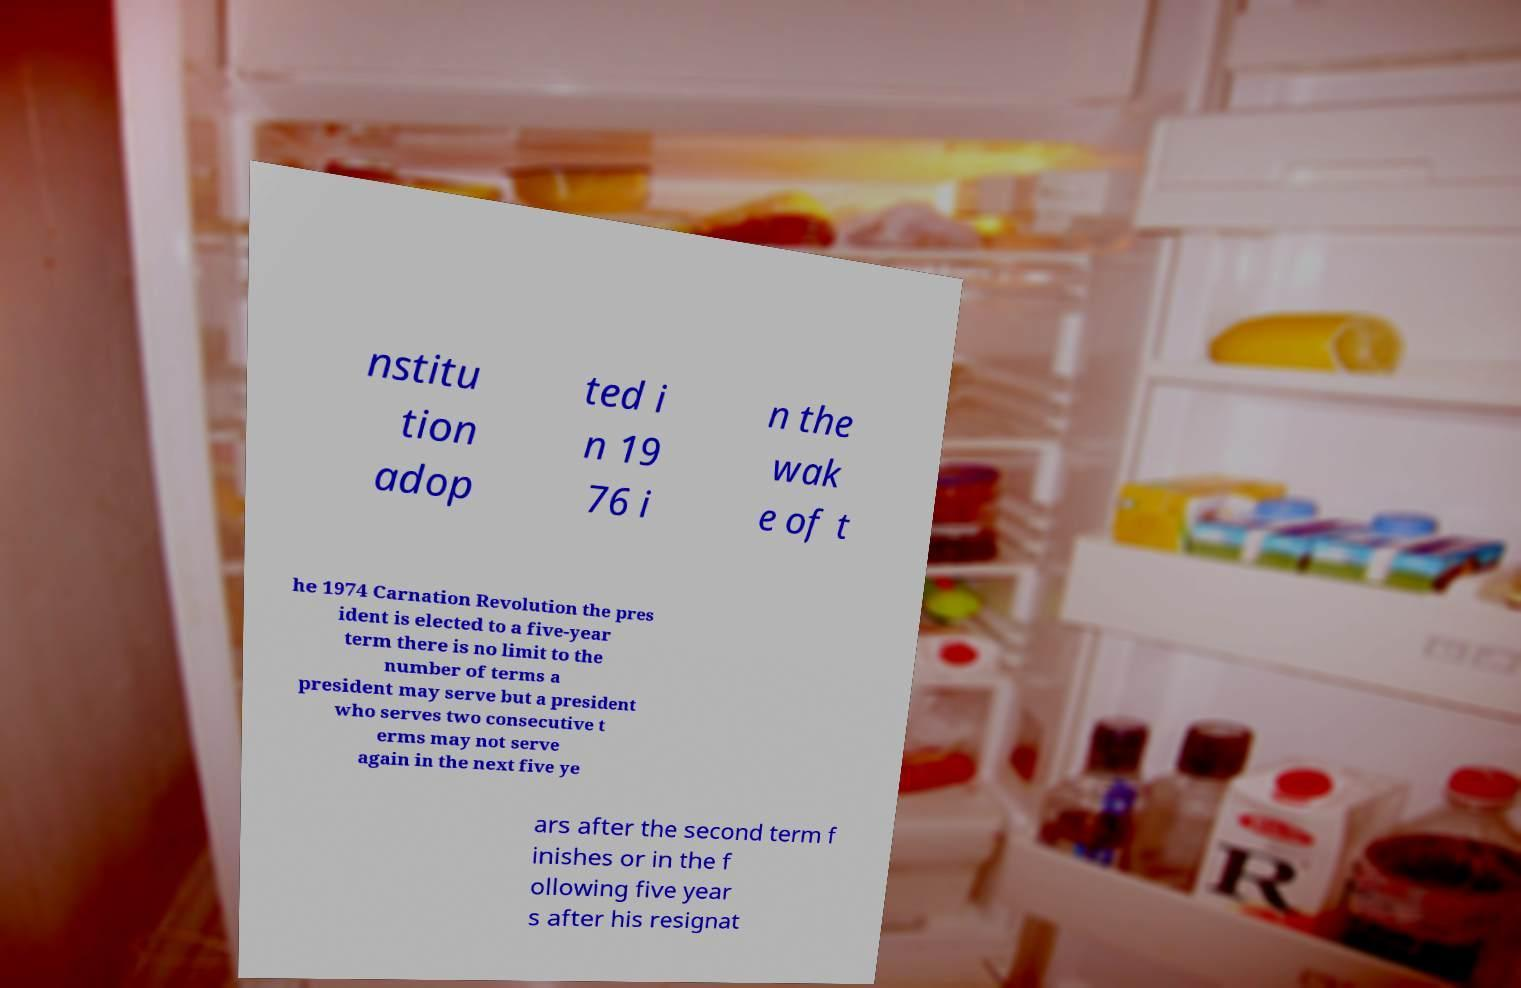There's text embedded in this image that I need extracted. Can you transcribe it verbatim? nstitu tion adop ted i n 19 76 i n the wak e of t he 1974 Carnation Revolution the pres ident is elected to a five-year term there is no limit to the number of terms a president may serve but a president who serves two consecutive t erms may not serve again in the next five ye ars after the second term f inishes or in the f ollowing five year s after his resignat 